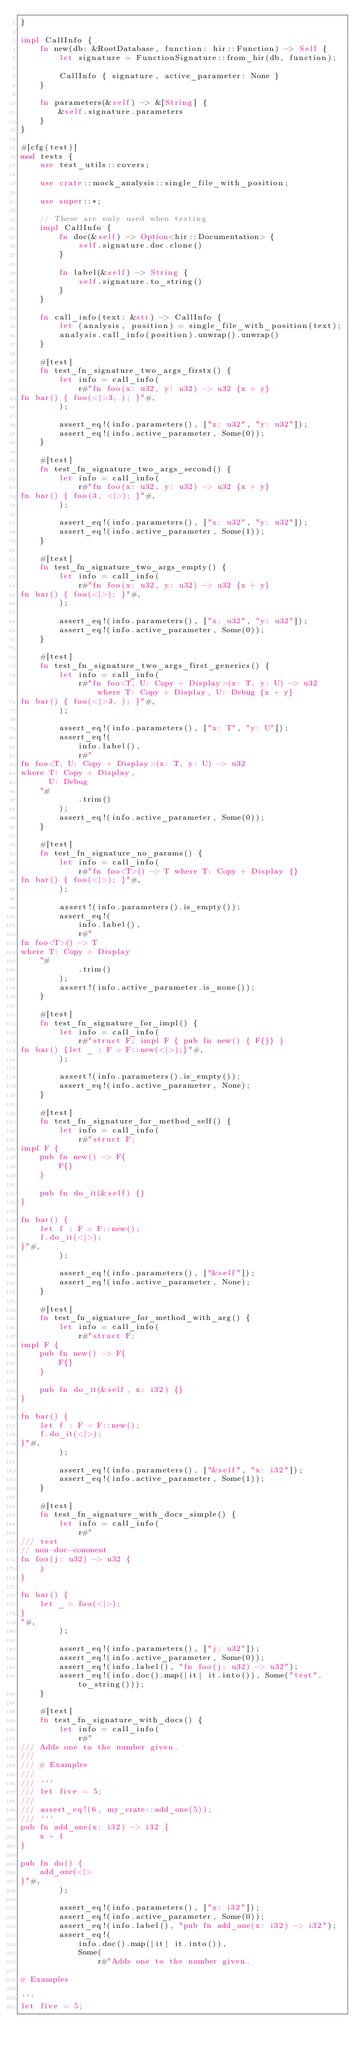<code> <loc_0><loc_0><loc_500><loc_500><_Rust_>}

impl CallInfo {
    fn new(db: &RootDatabase, function: hir::Function) -> Self {
        let signature = FunctionSignature::from_hir(db, function);

        CallInfo { signature, active_parameter: None }
    }

    fn parameters(&self) -> &[String] {
        &self.signature.parameters
    }
}

#[cfg(test)]
mod tests {
    use test_utils::covers;

    use crate::mock_analysis::single_file_with_position;

    use super::*;

    // These are only used when testing
    impl CallInfo {
        fn doc(&self) -> Option<hir::Documentation> {
            self.signature.doc.clone()
        }

        fn label(&self) -> String {
            self.signature.to_string()
        }
    }

    fn call_info(text: &str) -> CallInfo {
        let (analysis, position) = single_file_with_position(text);
        analysis.call_info(position).unwrap().unwrap()
    }

    #[test]
    fn test_fn_signature_two_args_firstx() {
        let info = call_info(
            r#"fn foo(x: u32, y: u32) -> u32 {x + y}
fn bar() { foo(<|>3, ); }"#,
        );

        assert_eq!(info.parameters(), ["x: u32", "y: u32"]);
        assert_eq!(info.active_parameter, Some(0));
    }

    #[test]
    fn test_fn_signature_two_args_second() {
        let info = call_info(
            r#"fn foo(x: u32, y: u32) -> u32 {x + y}
fn bar() { foo(3, <|>); }"#,
        );

        assert_eq!(info.parameters(), ["x: u32", "y: u32"]);
        assert_eq!(info.active_parameter, Some(1));
    }

    #[test]
    fn test_fn_signature_two_args_empty() {
        let info = call_info(
            r#"fn foo(x: u32, y: u32) -> u32 {x + y}
fn bar() { foo(<|>); }"#,
        );

        assert_eq!(info.parameters(), ["x: u32", "y: u32"]);
        assert_eq!(info.active_parameter, Some(0));
    }

    #[test]
    fn test_fn_signature_two_args_first_generics() {
        let info = call_info(
            r#"fn foo<T, U: Copy + Display>(x: T, y: U) -> u32 where T: Copy + Display, U: Debug {x + y}
fn bar() { foo(<|>3, ); }"#,
        );

        assert_eq!(info.parameters(), ["x: T", "y: U"]);
        assert_eq!(
            info.label(),
            r#"
fn foo<T, U: Copy + Display>(x: T, y: U) -> u32
where T: Copy + Display,
      U: Debug
    "#
            .trim()
        );
        assert_eq!(info.active_parameter, Some(0));
    }

    #[test]
    fn test_fn_signature_no_params() {
        let info = call_info(
            r#"fn foo<T>() -> T where T: Copy + Display {}
fn bar() { foo(<|>); }"#,
        );

        assert!(info.parameters().is_empty());
        assert_eq!(
            info.label(),
            r#"
fn foo<T>() -> T
where T: Copy + Display
    "#
            .trim()
        );
        assert!(info.active_parameter.is_none());
    }

    #[test]
    fn test_fn_signature_for_impl() {
        let info = call_info(
            r#"struct F; impl F { pub fn new() { F{}} }
fn bar() {let _ : F = F::new(<|>);}"#,
        );

        assert!(info.parameters().is_empty());
        assert_eq!(info.active_parameter, None);
    }

    #[test]
    fn test_fn_signature_for_method_self() {
        let info = call_info(
            r#"struct F;
impl F {
    pub fn new() -> F{
        F{}
    }

    pub fn do_it(&self) {}
}

fn bar() {
    let f : F = F::new();
    f.do_it(<|>);
}"#,
        );

        assert_eq!(info.parameters(), ["&self"]);
        assert_eq!(info.active_parameter, None);
    }

    #[test]
    fn test_fn_signature_for_method_with_arg() {
        let info = call_info(
            r#"struct F;
impl F {
    pub fn new() -> F{
        F{}
    }

    pub fn do_it(&self, x: i32) {}
}

fn bar() {
    let f : F = F::new();
    f.do_it(<|>);
}"#,
        );

        assert_eq!(info.parameters(), ["&self", "x: i32"]);
        assert_eq!(info.active_parameter, Some(1));
    }

    #[test]
    fn test_fn_signature_with_docs_simple() {
        let info = call_info(
            r#"
/// test
// non-doc-comment
fn foo(j: u32) -> u32 {
    j
}

fn bar() {
    let _ = foo(<|>);
}
"#,
        );

        assert_eq!(info.parameters(), ["j: u32"]);
        assert_eq!(info.active_parameter, Some(0));
        assert_eq!(info.label(), "fn foo(j: u32) -> u32");
        assert_eq!(info.doc().map(|it| it.into()), Some("test".to_string()));
    }

    #[test]
    fn test_fn_signature_with_docs() {
        let info = call_info(
            r#"
/// Adds one to the number given.
///
/// # Examples
///
/// ```
/// let five = 5;
///
/// assert_eq!(6, my_crate::add_one(5));
/// ```
pub fn add_one(x: i32) -> i32 {
    x + 1
}

pub fn do() {
    add_one(<|>
}"#,
        );

        assert_eq!(info.parameters(), ["x: i32"]);
        assert_eq!(info.active_parameter, Some(0));
        assert_eq!(info.label(), "pub fn add_one(x: i32) -> i32");
        assert_eq!(
            info.doc().map(|it| it.into()),
            Some(
                r#"Adds one to the number given.

# Examples

```
let five = 5;
</code> 